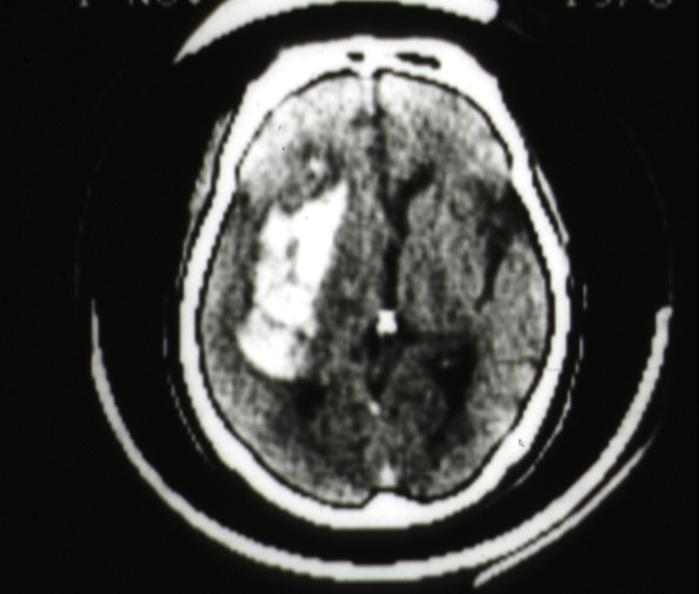what is present?
Answer the question using a single word or phrase. Brain 